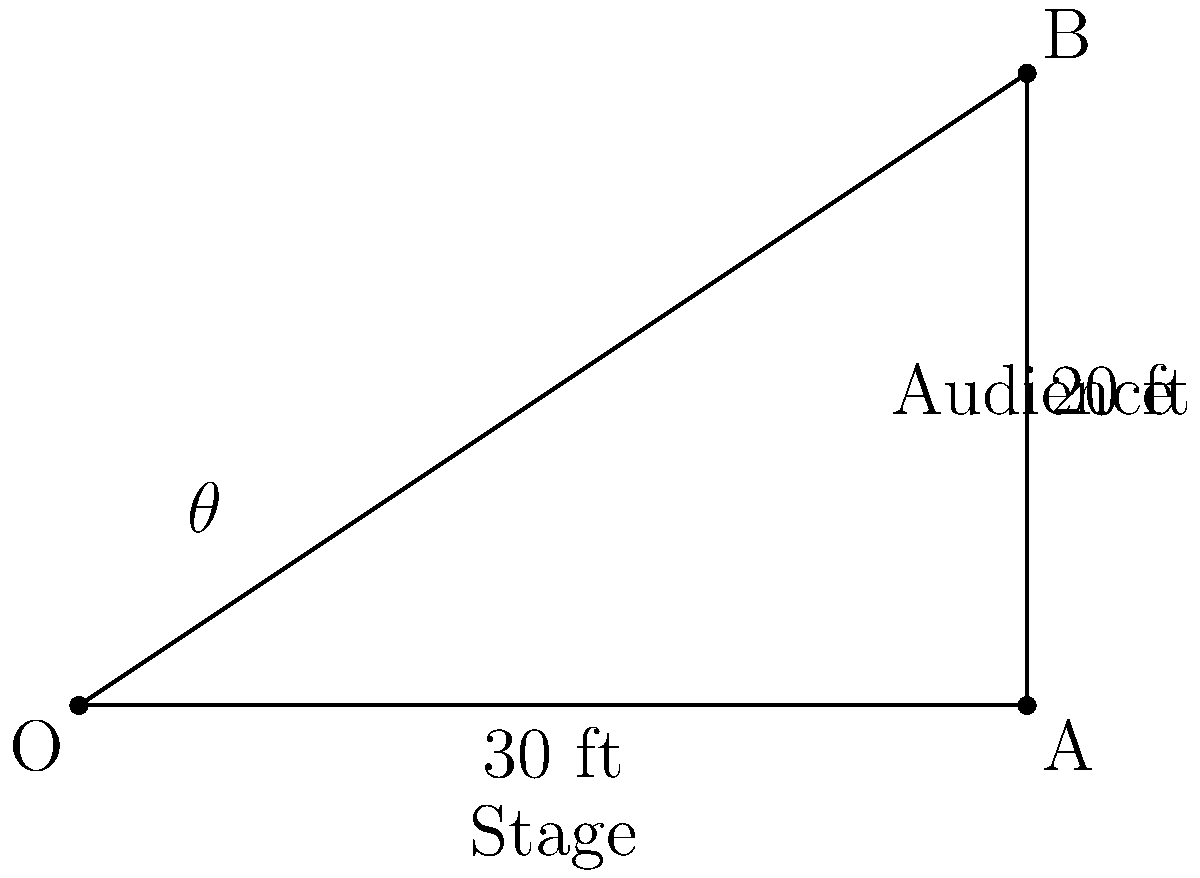In a TV studio, you're designing the seating arrangement for a new talk show. The stage is 30 feet wide, and the last row of the audience is seated 20 feet back from the edge of the stage. What is the optimal viewing angle $\theta$ (in degrees) for audience members seated at the far corner of the seating area to ensure they can see the entire stage comfortably? To solve this problem, we'll use trigonometry:

1) First, we need to identify the right triangle formed by the viewing angle. In this case, it's triangle OAB, where:
   - O is the corner of the stage
   - A is the edge of the stage (30 feet from O)
   - B is the corner of the audience seating area

2) We know two sides of this right triangle:
   - OA (adjacent to angle $\theta$) = 30 feet
   - AB (opposite to angle $\theta$) = 20 feet

3) To find angle $\theta$, we can use the arctangent function:

   $\theta = \arctan(\frac{\text{opposite}}{\text{adjacent}})$

4) Plugging in our values:

   $\theta = \arctan(\frac{20}{30})$

5) Simplify the fraction:

   $\theta = \arctan(\frac{2}{3})$

6) Calculate the result:

   $\theta \approx 33.69$ degrees

7) Round to the nearest degree for a practical answer in a TV studio setting:

   $\theta \approx 34$ degrees

This angle ensures that audience members in the far corner can comfortably view the entire stage.
Answer: 34° 